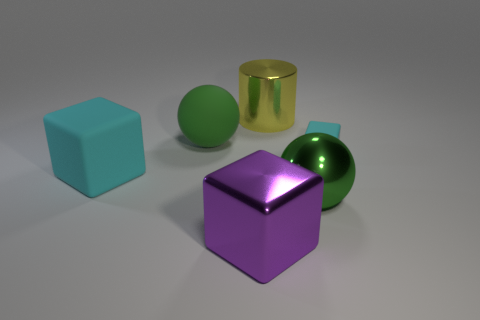Are there any yellow cylinders that have the same size as the green rubber thing?
Offer a very short reply. Yes. What is the color of the other thing that is the same shape as the green metal object?
Offer a terse response. Green. Are there any metal objects behind the cyan cube that is on the left side of the purple metal cube?
Provide a succinct answer. Yes. Is the shape of the big metal thing left of the large yellow cylinder the same as  the large cyan rubber object?
Your answer should be very brief. Yes. The small cyan object has what shape?
Your response must be concise. Cube. How many tiny blue blocks have the same material as the big cyan block?
Keep it short and to the point. 0. There is a big metallic ball; does it have the same color as the large sphere left of the big yellow cylinder?
Your response must be concise. Yes. How many green rubber objects are there?
Give a very brief answer. 1. Is there another big ball of the same color as the big metallic sphere?
Offer a terse response. Yes. What is the color of the block that is to the right of the thing in front of the green sphere in front of the matte ball?
Provide a short and direct response. Cyan. 